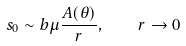Convert formula to latex. <formula><loc_0><loc_0><loc_500><loc_500>s _ { 0 } \sim b \mu \frac { A ( \theta ) } { r } , \quad r \to 0</formula> 